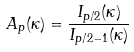Convert formula to latex. <formula><loc_0><loc_0><loc_500><loc_500>A _ { p } ( \kappa ) = \frac { I _ { p / 2 } ( \kappa ) } { I _ { p / 2 - 1 } ( \kappa ) }</formula> 